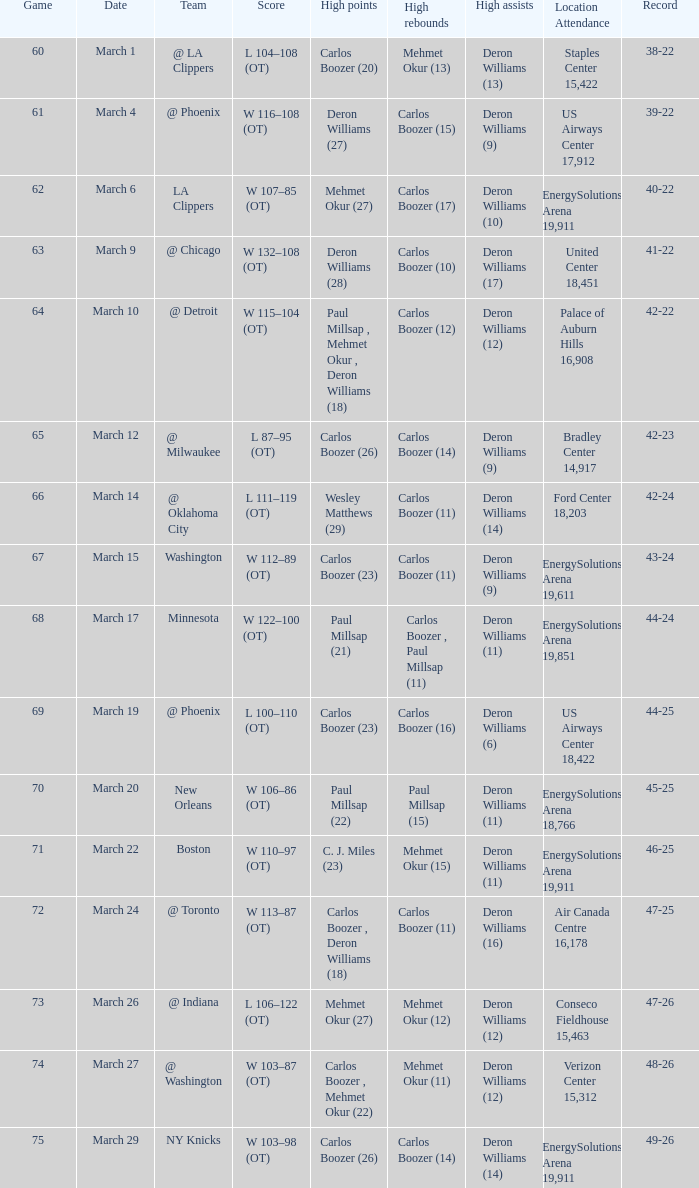Could you parse the entire table as a dict? {'header': ['Game', 'Date', 'Team', 'Score', 'High points', 'High rebounds', 'High assists', 'Location Attendance', 'Record'], 'rows': [['60', 'March 1', '@ LA Clippers', 'L 104–108 (OT)', 'Carlos Boozer (20)', 'Mehmet Okur (13)', 'Deron Williams (13)', 'Staples Center 15,422', '38-22'], ['61', 'March 4', '@ Phoenix', 'W 116–108 (OT)', 'Deron Williams (27)', 'Carlos Boozer (15)', 'Deron Williams (9)', 'US Airways Center 17,912', '39-22'], ['62', 'March 6', 'LA Clippers', 'W 107–85 (OT)', 'Mehmet Okur (27)', 'Carlos Boozer (17)', 'Deron Williams (10)', 'EnergySolutions Arena 19,911', '40-22'], ['63', 'March 9', '@ Chicago', 'W 132–108 (OT)', 'Deron Williams (28)', 'Carlos Boozer (10)', 'Deron Williams (17)', 'United Center 18,451', '41-22'], ['64', 'March 10', '@ Detroit', 'W 115–104 (OT)', 'Paul Millsap , Mehmet Okur , Deron Williams (18)', 'Carlos Boozer (12)', 'Deron Williams (12)', 'Palace of Auburn Hills 16,908', '42-22'], ['65', 'March 12', '@ Milwaukee', 'L 87–95 (OT)', 'Carlos Boozer (26)', 'Carlos Boozer (14)', 'Deron Williams (9)', 'Bradley Center 14,917', '42-23'], ['66', 'March 14', '@ Oklahoma City', 'L 111–119 (OT)', 'Wesley Matthews (29)', 'Carlos Boozer (11)', 'Deron Williams (14)', 'Ford Center 18,203', '42-24'], ['67', 'March 15', 'Washington', 'W 112–89 (OT)', 'Carlos Boozer (23)', 'Carlos Boozer (11)', 'Deron Williams (9)', 'EnergySolutions Arena 19,611', '43-24'], ['68', 'March 17', 'Minnesota', 'W 122–100 (OT)', 'Paul Millsap (21)', 'Carlos Boozer , Paul Millsap (11)', 'Deron Williams (11)', 'EnergySolutions Arena 19,851', '44-24'], ['69', 'March 19', '@ Phoenix', 'L 100–110 (OT)', 'Carlos Boozer (23)', 'Carlos Boozer (16)', 'Deron Williams (6)', 'US Airways Center 18,422', '44-25'], ['70', 'March 20', 'New Orleans', 'W 106–86 (OT)', 'Paul Millsap (22)', 'Paul Millsap (15)', 'Deron Williams (11)', 'EnergySolutions Arena 18,766', '45-25'], ['71', 'March 22', 'Boston', 'W 110–97 (OT)', 'C. J. Miles (23)', 'Mehmet Okur (15)', 'Deron Williams (11)', 'EnergySolutions Arena 19,911', '46-25'], ['72', 'March 24', '@ Toronto', 'W 113–87 (OT)', 'Carlos Boozer , Deron Williams (18)', 'Carlos Boozer (11)', 'Deron Williams (16)', 'Air Canada Centre 16,178', '47-25'], ['73', 'March 26', '@ Indiana', 'L 106–122 (OT)', 'Mehmet Okur (27)', 'Mehmet Okur (12)', 'Deron Williams (12)', 'Conseco Fieldhouse 15,463', '47-26'], ['74', 'March 27', '@ Washington', 'W 103–87 (OT)', 'Carlos Boozer , Mehmet Okur (22)', 'Mehmet Okur (11)', 'Deron Williams (12)', 'Verizon Center 15,312', '48-26'], ['75', 'March 29', 'NY Knicks', 'W 103–98 (OT)', 'Carlos Boozer (26)', 'Carlos Boozer (14)', 'Deron Williams (14)', 'EnergySolutions Arena 19,911', '49-26']]} How many participants scored the most points in the match with a 39-22 record? 1.0. 